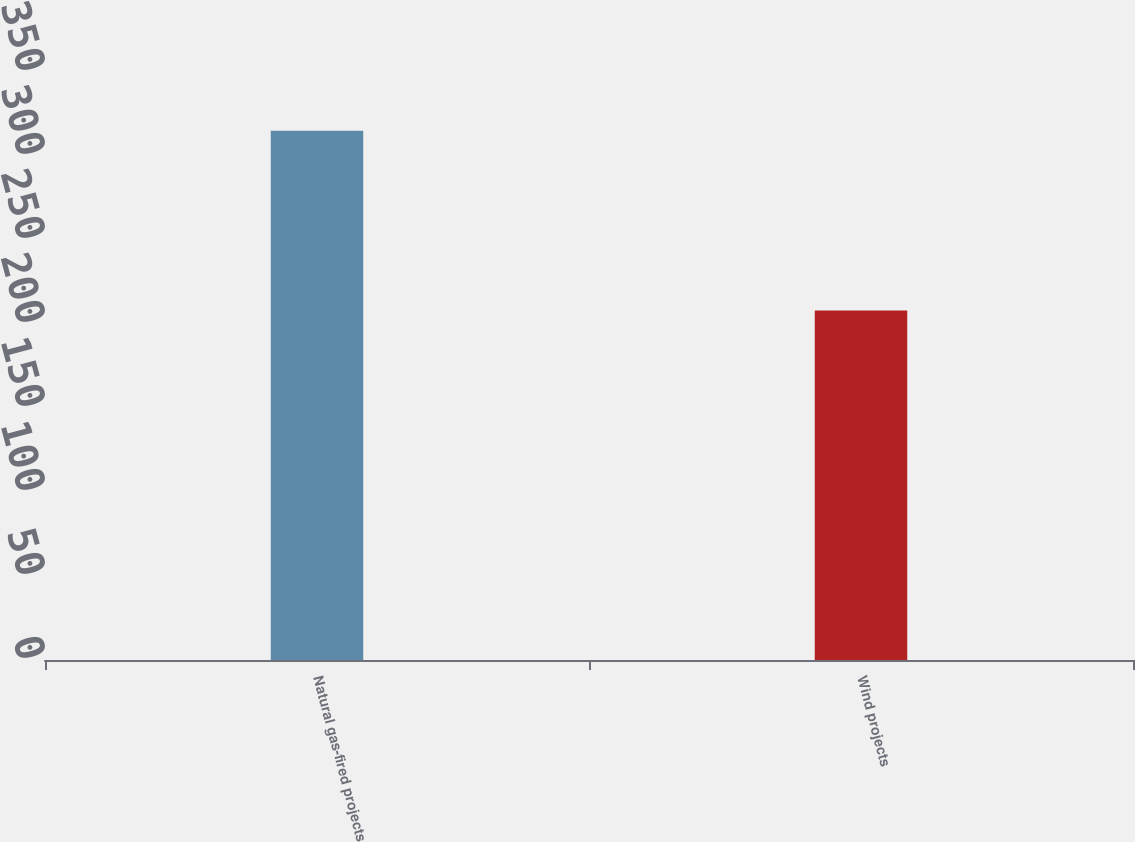Convert chart. <chart><loc_0><loc_0><loc_500><loc_500><bar_chart><fcel>Natural gas-fired projects<fcel>Wind projects<nl><fcel>315<fcel>208<nl></chart> 